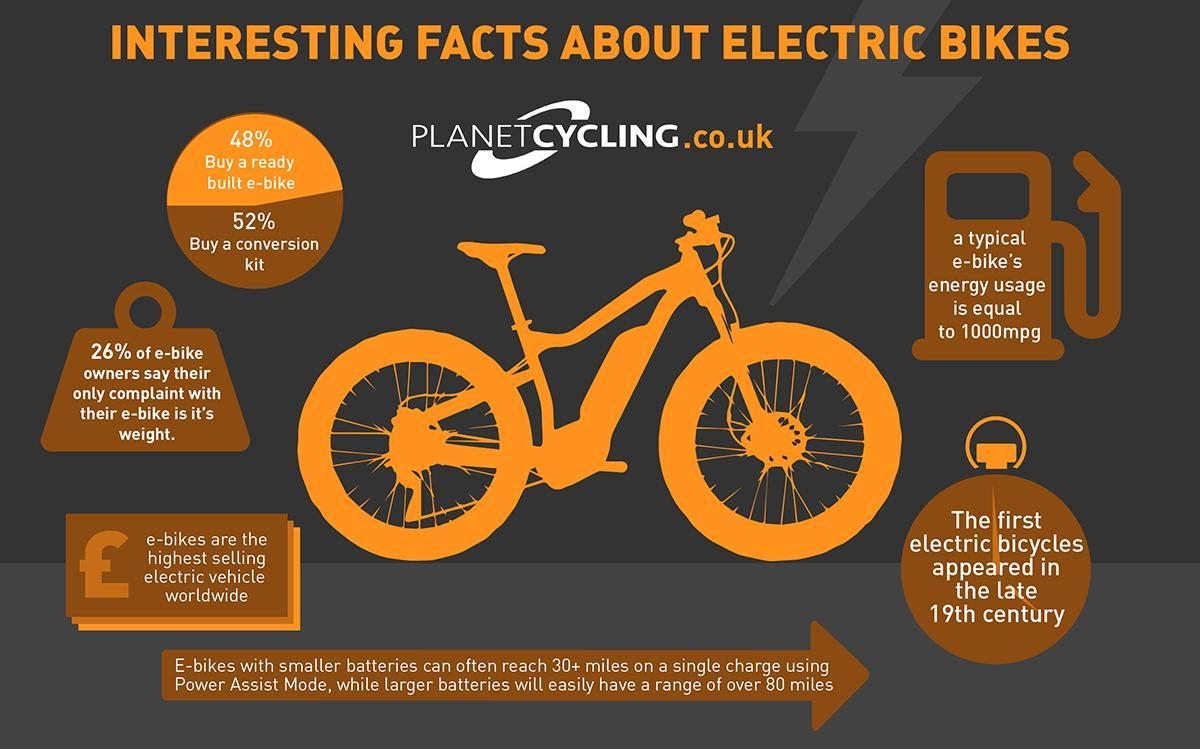What percentage of people do not buy a ready built e- bike?
Answer the question with a short phrase. 52% 